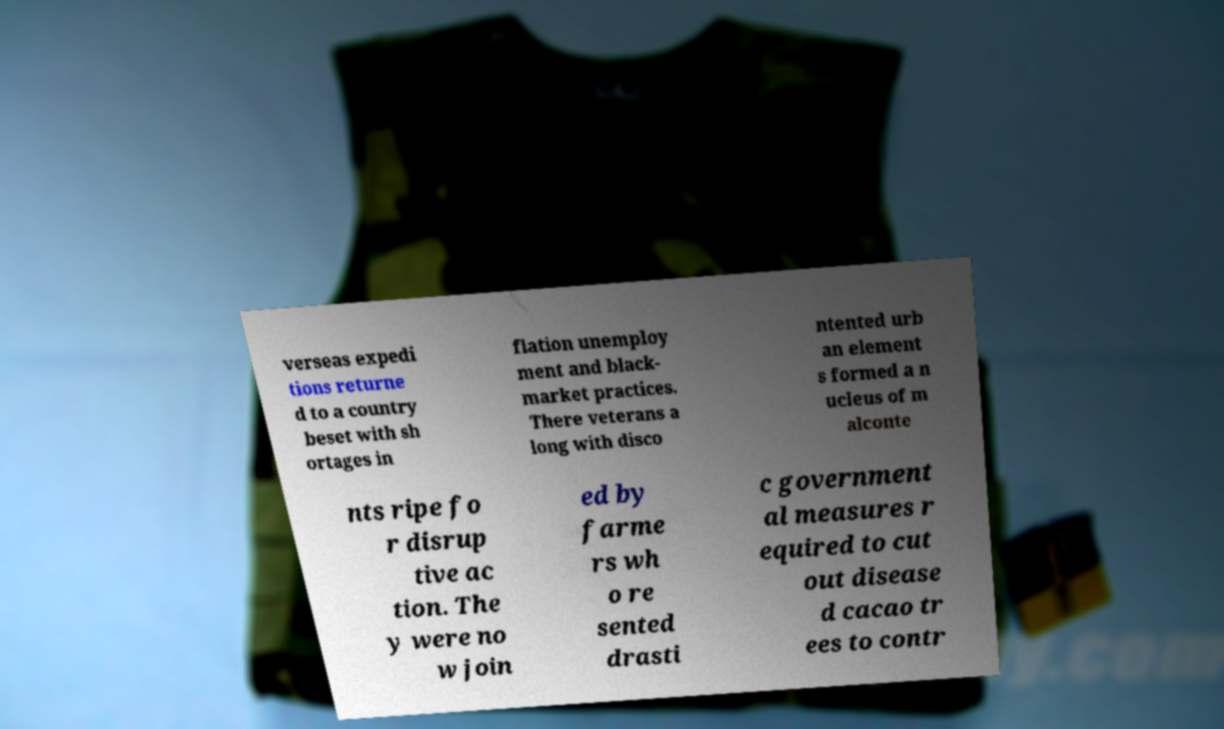For documentation purposes, I need the text within this image transcribed. Could you provide that? verseas expedi tions returne d to a country beset with sh ortages in flation unemploy ment and black- market practices. There veterans a long with disco ntented urb an element s formed a n ucleus of m alconte nts ripe fo r disrup tive ac tion. The y were no w join ed by farme rs wh o re sented drasti c government al measures r equired to cut out disease d cacao tr ees to contr 